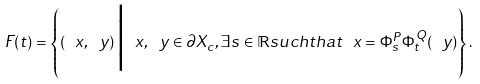<formula> <loc_0><loc_0><loc_500><loc_500>\ F ( t ) = \left \{ \left ( \ x , \ y \right ) \Big | \ x , \ y \in \partial X _ { c } , \exists s \in \mathbb { R } s u c h t h a t \ x = \Phi _ { s } ^ { P } \Phi _ { t } ^ { Q } ( \ y ) \right \} .</formula> 